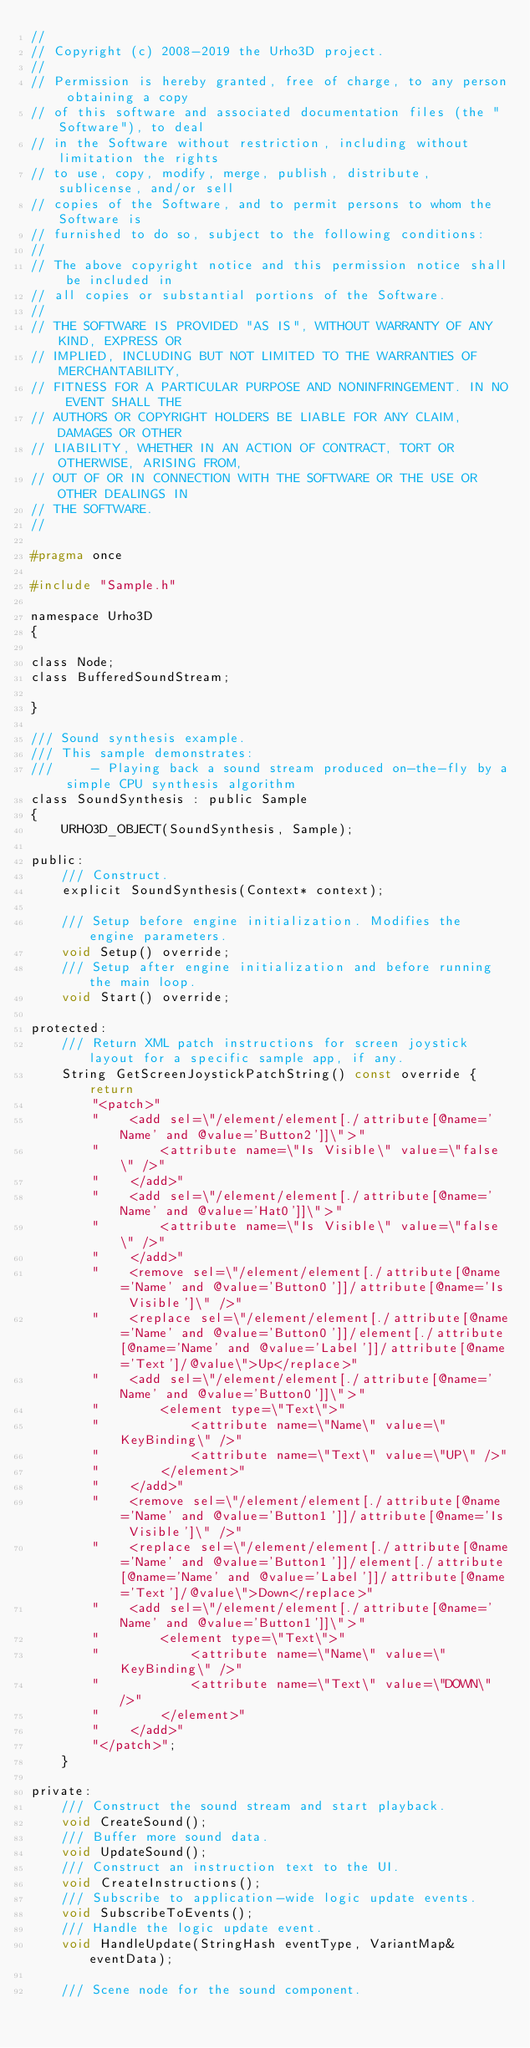Convert code to text. <code><loc_0><loc_0><loc_500><loc_500><_C_>//
// Copyright (c) 2008-2019 the Urho3D project.
//
// Permission is hereby granted, free of charge, to any person obtaining a copy
// of this software and associated documentation files (the "Software"), to deal
// in the Software without restriction, including without limitation the rights
// to use, copy, modify, merge, publish, distribute, sublicense, and/or sell
// copies of the Software, and to permit persons to whom the Software is
// furnished to do so, subject to the following conditions:
//
// The above copyright notice and this permission notice shall be included in
// all copies or substantial portions of the Software.
//
// THE SOFTWARE IS PROVIDED "AS IS", WITHOUT WARRANTY OF ANY KIND, EXPRESS OR
// IMPLIED, INCLUDING BUT NOT LIMITED TO THE WARRANTIES OF MERCHANTABILITY,
// FITNESS FOR A PARTICULAR PURPOSE AND NONINFRINGEMENT. IN NO EVENT SHALL THE
// AUTHORS OR COPYRIGHT HOLDERS BE LIABLE FOR ANY CLAIM, DAMAGES OR OTHER
// LIABILITY, WHETHER IN AN ACTION OF CONTRACT, TORT OR OTHERWISE, ARISING FROM,
// OUT OF OR IN CONNECTION WITH THE SOFTWARE OR THE USE OR OTHER DEALINGS IN
// THE SOFTWARE.
//

#pragma once

#include "Sample.h"

namespace Urho3D
{

class Node;
class BufferedSoundStream;

}

/// Sound synthesis example.
/// This sample demonstrates:
///     - Playing back a sound stream produced on-the-fly by a simple CPU synthesis algorithm
class SoundSynthesis : public Sample
{
    URHO3D_OBJECT(SoundSynthesis, Sample);

public:
    /// Construct.
    explicit SoundSynthesis(Context* context);

    /// Setup before engine initialization. Modifies the engine parameters.
    void Setup() override;
    /// Setup after engine initialization and before running the main loop.
    void Start() override;

protected:
    /// Return XML patch instructions for screen joystick layout for a specific sample app, if any.
    String GetScreenJoystickPatchString() const override { return
        "<patch>"
        "    <add sel=\"/element/element[./attribute[@name='Name' and @value='Button2']]\">"
        "        <attribute name=\"Is Visible\" value=\"false\" />"
        "    </add>"
        "    <add sel=\"/element/element[./attribute[@name='Name' and @value='Hat0']]\">"
        "        <attribute name=\"Is Visible\" value=\"false\" />"
        "    </add>"
        "    <remove sel=\"/element/element[./attribute[@name='Name' and @value='Button0']]/attribute[@name='Is Visible']\" />"
        "    <replace sel=\"/element/element[./attribute[@name='Name' and @value='Button0']]/element[./attribute[@name='Name' and @value='Label']]/attribute[@name='Text']/@value\">Up</replace>"
        "    <add sel=\"/element/element[./attribute[@name='Name' and @value='Button0']]\">"
        "        <element type=\"Text\">"
        "            <attribute name=\"Name\" value=\"KeyBinding\" />"
        "            <attribute name=\"Text\" value=\"UP\" />"
        "        </element>"
        "    </add>"
        "    <remove sel=\"/element/element[./attribute[@name='Name' and @value='Button1']]/attribute[@name='Is Visible']\" />"
        "    <replace sel=\"/element/element[./attribute[@name='Name' and @value='Button1']]/element[./attribute[@name='Name' and @value='Label']]/attribute[@name='Text']/@value\">Down</replace>"
        "    <add sel=\"/element/element[./attribute[@name='Name' and @value='Button1']]\">"
        "        <element type=\"Text\">"
        "            <attribute name=\"Name\" value=\"KeyBinding\" />"
        "            <attribute name=\"Text\" value=\"DOWN\" />"
        "        </element>"
        "    </add>"
        "</patch>";
    }

private:
    /// Construct the sound stream and start playback.
    void CreateSound();
    /// Buffer more sound data.
    void UpdateSound();
    /// Construct an instruction text to the UI.
    void CreateInstructions();
    /// Subscribe to application-wide logic update events.
    void SubscribeToEvents();
    /// Handle the logic update event.
    void HandleUpdate(StringHash eventType, VariantMap& eventData);

    /// Scene node for the sound component.</code> 